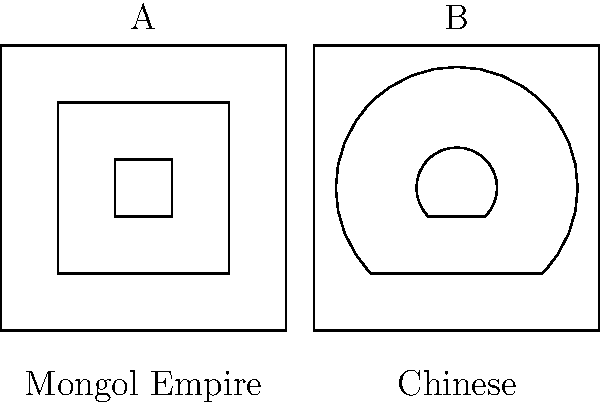Based on the side-by-side comparison of artifacts shown above, which artistic element was likely introduced to Chinese art as a result of Mongol influence during the Yuan Dynasty (1271-1368)? To answer this question, we need to analyze the artistic elements in both images and consider the historical context of the Mongol Empire's influence on Chinese art during the Yuan Dynasty:

1. Image A (Mongol Empire):
   - Characterized by geometric shapes
   - Strong emphasis on straight lines and angles
   - Nested square patterns

2. Image B (Chinese):
   - Incorporates both straight lines and curves
   - Outer shape is square, but inner shapes have curved elements
   - Blend of geometric and organic forms

3. Historical context:
   - The Mongol Empire conquered China, establishing the Yuan Dynasty (1271-1368)
   - This period saw significant cultural exchange between Mongol and Chinese artistic traditions

4. Analysis:
   - The introduction of more geometric elements and straight lines in Chinese art can be attributed to Mongol influence
   - The combination of traditional Chinese curved forms with Mongol-inspired geometric shapes is evident in Image B

5. Conclusion:
   - The geometric elements and emphasis on straight lines in Image B, which are characteristic of Mongol art (Image A), were likely introduced to Chinese art during the Yuan Dynasty as a result of Mongol influence

Therefore, the artistic element introduced to Chinese art as a result of Mongol influence was the increased use of geometric shapes and straight lines, as seen in the blending of styles in Image B.
Answer: Geometric shapes and straight lines 